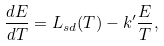Convert formula to latex. <formula><loc_0><loc_0><loc_500><loc_500>\frac { d E } { d T } = L _ { s d } ( T ) - k ^ { \prime } \frac { E } { T } ,</formula> 